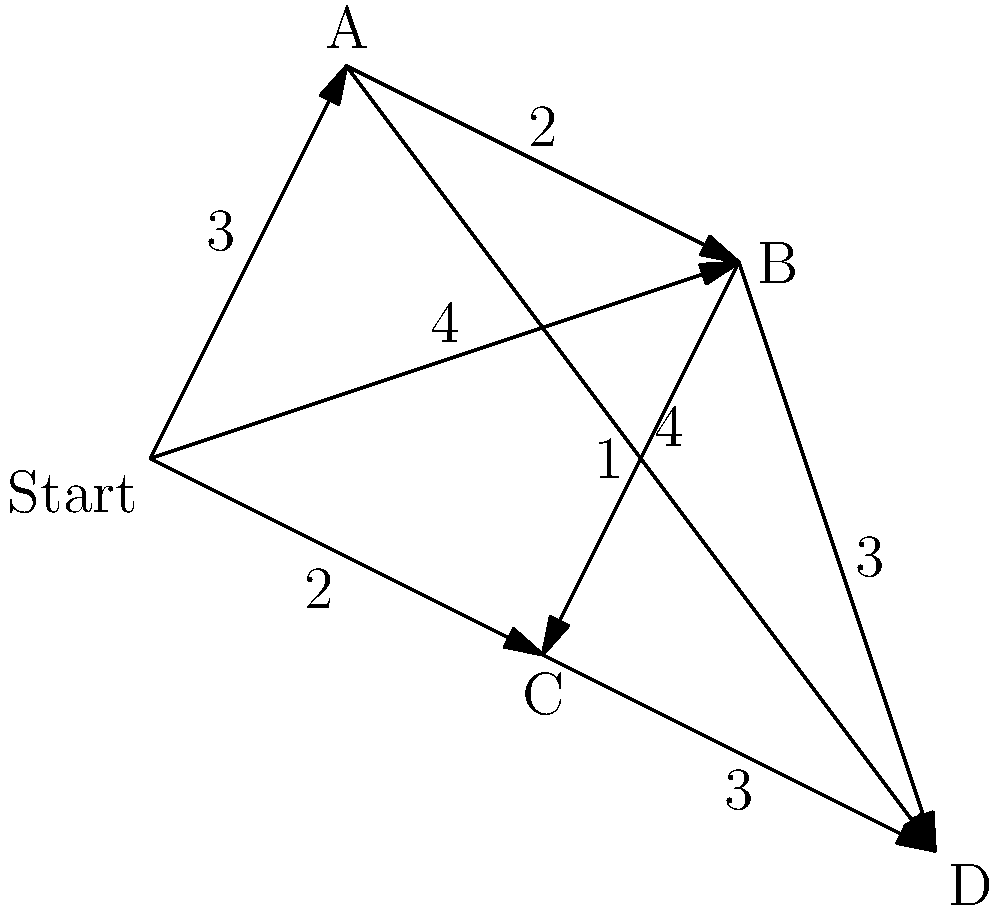As a photographer, you need to capture images of four landmarks (A, B, C, and D) in a city, starting from your hotel. The graph shows the distances (in kilometers) between locations. What is the shortest path to visit all landmarks and return to the hotel, and what is the total distance traveled? To solve this problem, we'll use the nearest neighbor algorithm, which is a simple heuristic for the Traveling Salesman Problem:

1. Start at the hotel (Start node).
2. Choose the nearest unvisited landmark:
   - Nearest to Start: C (2 km)
3. From C, choose the nearest unvisited landmark:
   - Nearest to C: B (1 km)
4. From B, choose the nearest unvisited landmark:
   - Nearest to B: A (2 km)
5. From A, visit the last remaining landmark:
   - D (4 km)
6. Return to the hotel from D:
   - D to Start: 2 km (via C)

The path is: Start → C → B → A → D → C → Start

Total distance:
$$ 2 + 1 + 2 + 4 + 3 + 2 = 14 \text{ km} $$

Note: This may not be the optimal solution, as the nearest neighbor algorithm doesn't guarantee the shortest path. However, it provides a good approximation and is easy to implement.
Answer: Path: Start → C → B → A → D → C → Start; Distance: 14 km 